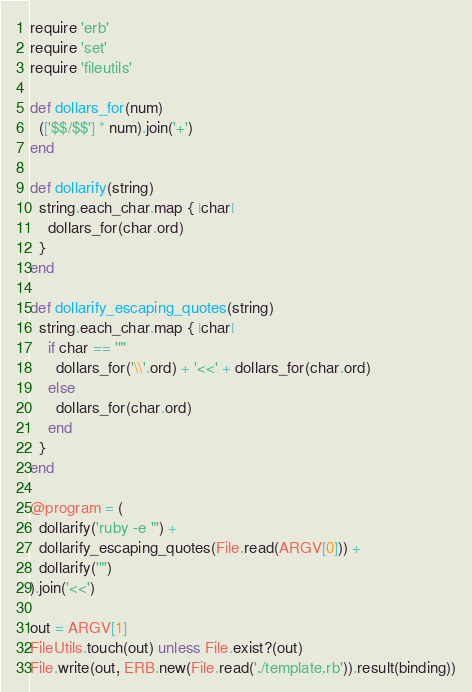Convert code to text. <code><loc_0><loc_0><loc_500><loc_500><_Ruby_>require 'erb'
require 'set'
require 'fileutils'

def dollars_for(num)
  (['$$/$$'] * num).join('+')
end

def dollarify(string)
  string.each_char.map { |char|
    dollars_for(char.ord)
  }
end

def dollarify_escaping_quotes(string)
  string.each_char.map { |char|
    if char == '"'
      dollars_for('\\'.ord) + '<<' + dollars_for(char.ord)
    else
      dollars_for(char.ord)
    end
  }
end

@program = (
  dollarify('ruby -e "') +
  dollarify_escaping_quotes(File.read(ARGV[0])) +
  dollarify('"')
).join('<<')

out = ARGV[1]
FileUtils.touch(out) unless File.exist?(out)
File.write(out, ERB.new(File.read('./template.rb')).result(binding))
</code> 